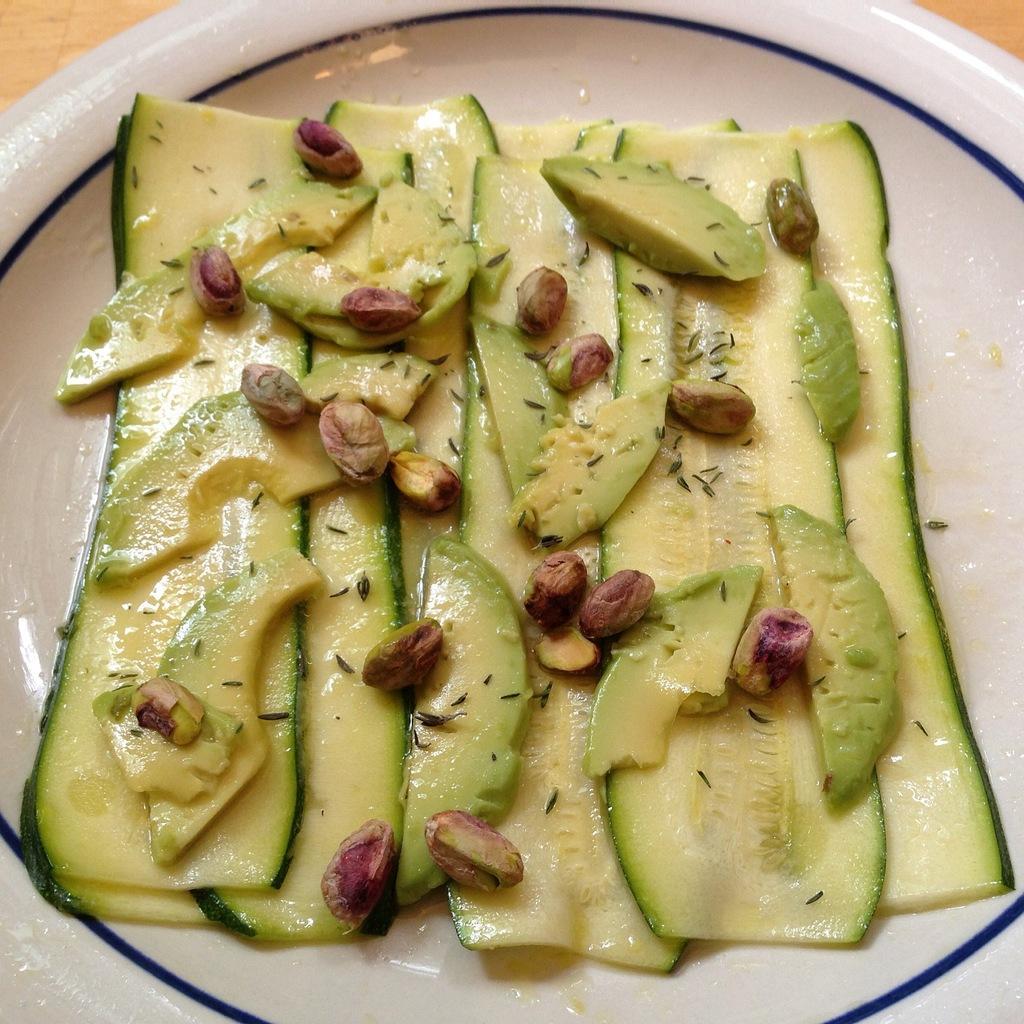Can you describe this image briefly? In the image there is a white plate. On the plate there are slices of cucumber, avocado and also there are pistachio seeds. 